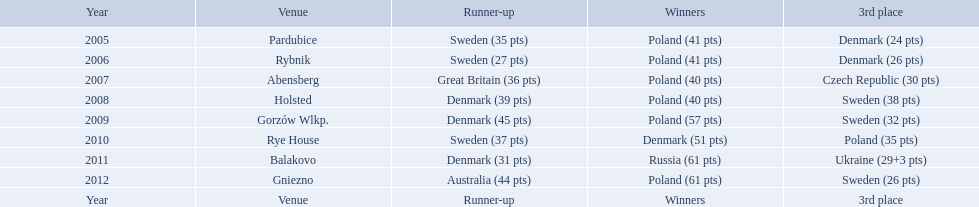Did holland win the 2010 championship? if not who did? Rye House. What did position did holland they rank? 3rd place. In what years did denmark place in the top 3 in the team speedway junior world championship? 2005, 2006, 2008, 2009, 2010, 2011. What in what year did denmark come withing 2 points of placing higher in the standings? 2006. What place did denmark receive the year they missed higher ranking by only 2 points? 3rd place. 